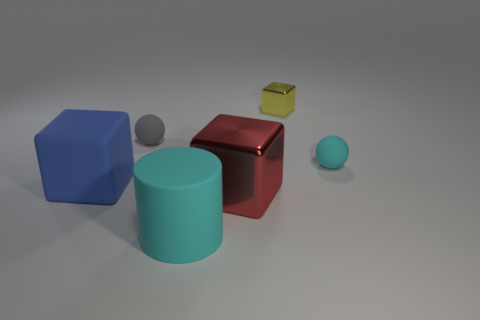Add 4 big cyan rubber cylinders. How many objects exist? 10 Subtract all cylinders. How many objects are left? 5 Add 6 tiny gray balls. How many tiny gray balls exist? 7 Subtract 1 gray balls. How many objects are left? 5 Subtract all cyan things. Subtract all rubber blocks. How many objects are left? 3 Add 5 large metal blocks. How many large metal blocks are left? 6 